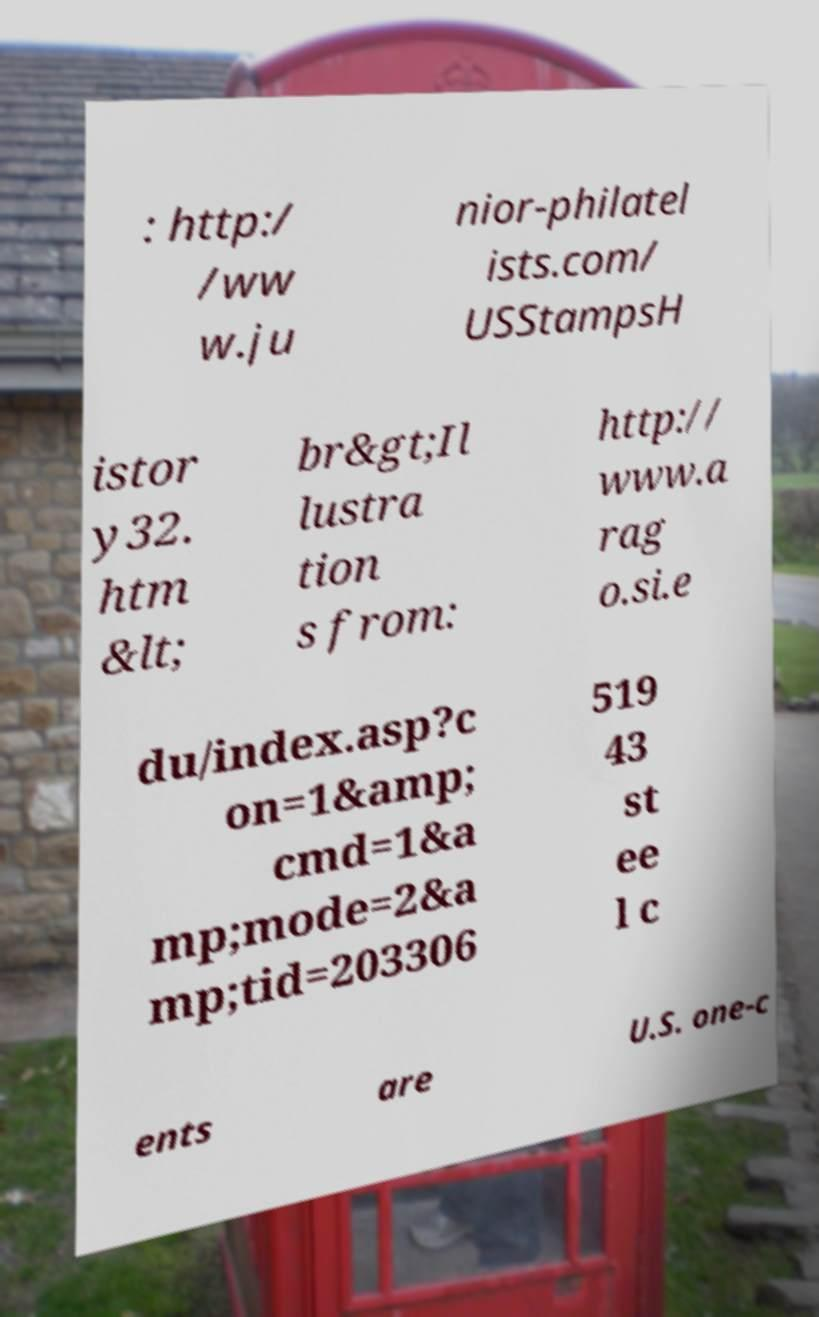Please identify and transcribe the text found in this image. : http:/ /ww w.ju nior-philatel ists.com/ USStampsH istor y32. htm &lt; br&gt;Il lustra tion s from: http:// www.a rag o.si.e du/index.asp?c on=1&amp; cmd=1&a mp;mode=2&a mp;tid=203306 519 43 st ee l c ents are U.S. one-c 